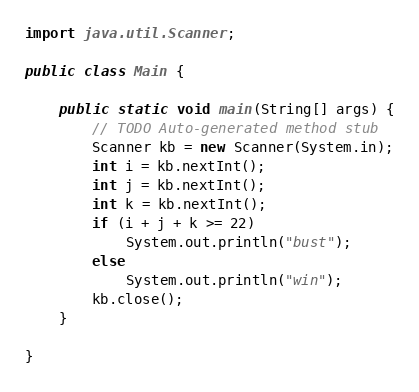<code> <loc_0><loc_0><loc_500><loc_500><_Java_>import java.util.Scanner;

public class Main {

	public static void main(String[] args) {
		// TODO Auto-generated method stub
		Scanner kb = new Scanner(System.in);
		int i = kb.nextInt();
		int j = kb.nextInt();
		int k = kb.nextInt();
		if (i + j + k >= 22)
			System.out.println("bust");
		else
			System.out.println("win");
		kb.close();
	}

}
</code> 